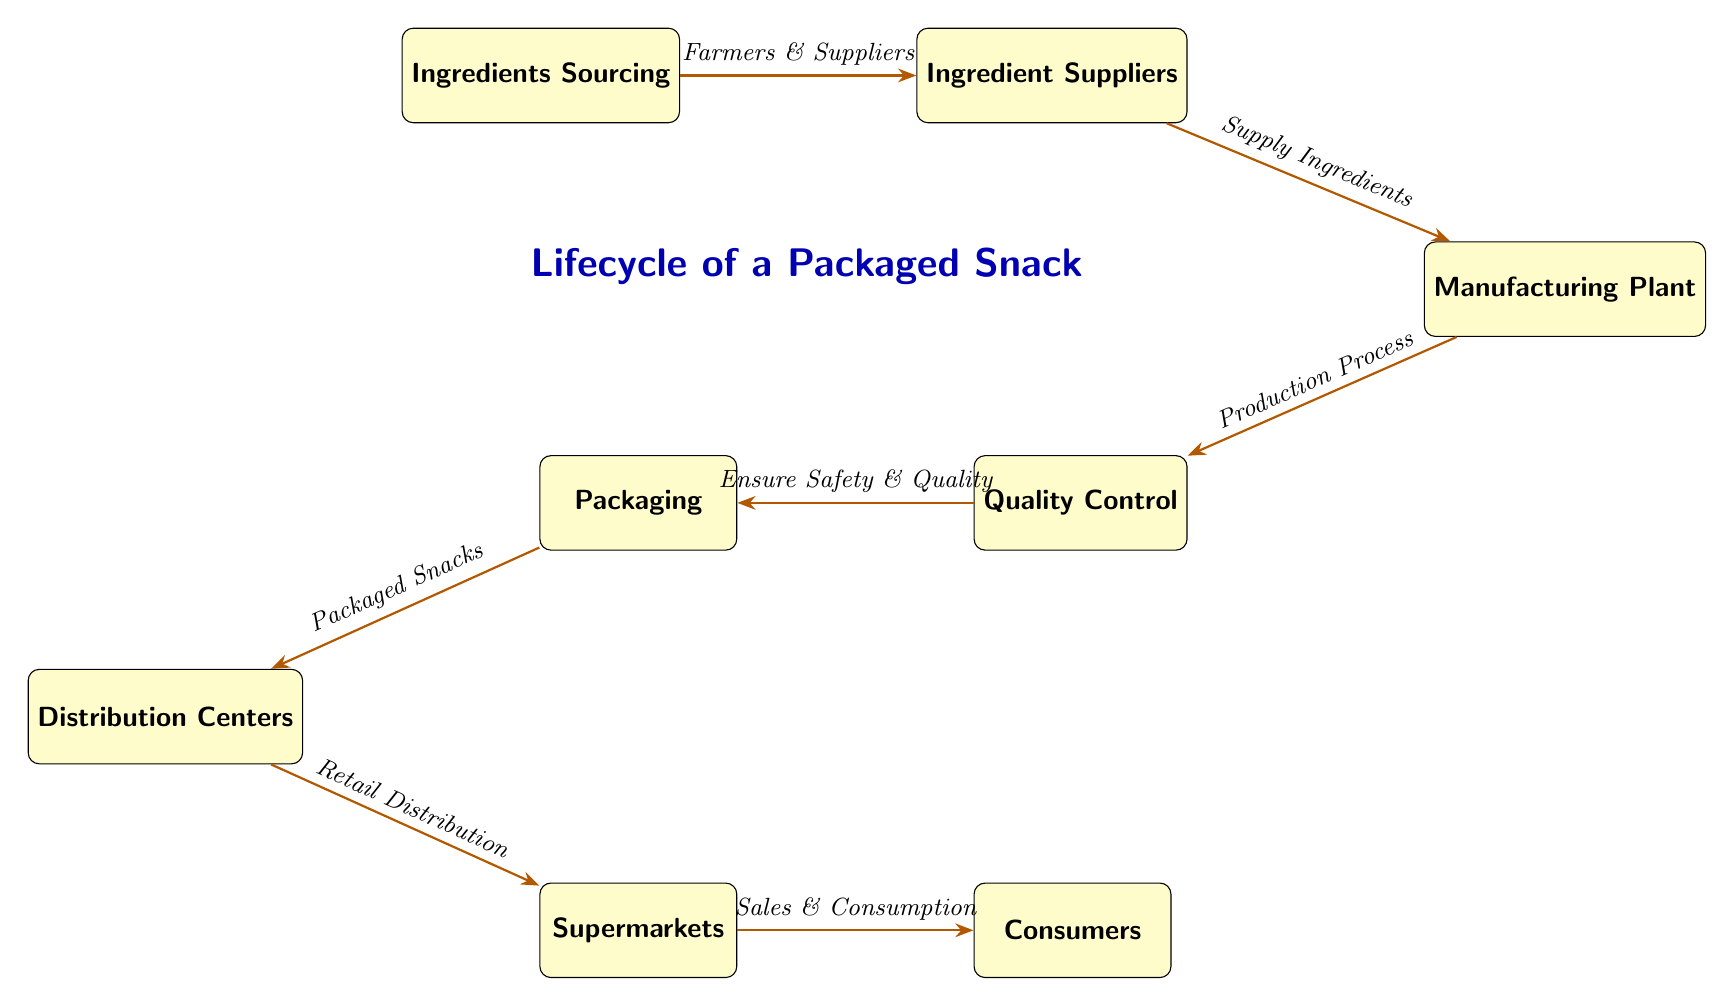What is the first step in the lifecycle of a packaged snack? The first step is "Ingredients Sourcing," which is represented as the starting node in the diagram.
Answer: Ingredients Sourcing How many nodes are there in the diagram? By counting each distinct box in the diagram, we find there are a total of eight nodes representing different stages in the lifecycle.
Answer: 8 What is the process following the distribution centers? The next step after Distribution Centers is "Supermarkets," as indicated by the arrow leading from Distribution Centers to Supermarkets.
Answer: Supermarkets Who are the sources for the ingredients? The diagram indicates that "Farmers & Suppliers" are the sources for the ingredients, as shown along the arrow from Ingredients Sourcing to Ingredient Suppliers.
Answer: Farmers & Suppliers What happens after the manufacturing plant? After the Manufacturing Plant, the next phase is Quality Control, as illustrated by the flow from Manufacturing Plant to Quality Control.
Answer: Quality Control What is packed after the quality control stage? After the Quality Control stage, "Packaged Snacks" are produced, as indicated by the transition from Quality Control to Packaging.
Answer: Packaged Snacks What is the last step before consumers get the snacks? The last step before consumers get the snacks is "Sales & Consumption," which follows the Supermarkets according to the arrow directions in the diagram.
Answer: Sales & Consumption What is required before the packaging of the snacks? Before packaging, it is necessary to "Ensure Safety & Quality," which is a step that follows Quality Control in the lifecycle.
Answer: Ensure Safety & Quality What do Distribution Centers focus on? Distribution Centers focus on "Retail Distribution," as represented by the arrow leading to the next stage, Supermarkets.
Answer: Retail Distribution 